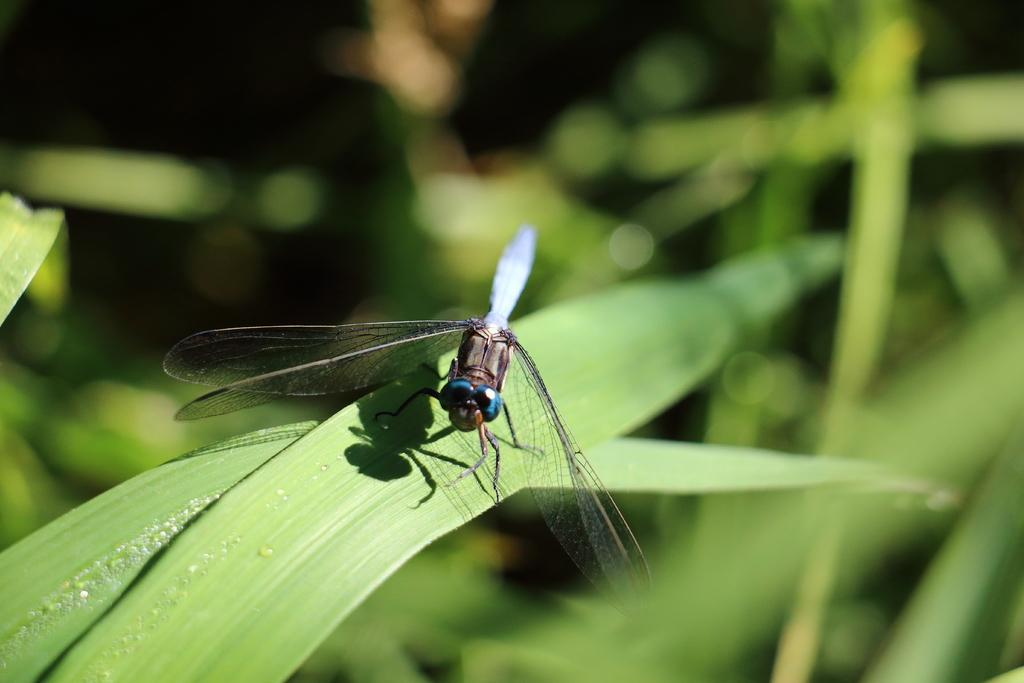What insect is present in the picture? There is a dragonfly in the picture. What are the main features of the dragonfly? The dragonfly has wings, eyes, legs, and an abdomen. What else can be seen in the picture besides the dragonfly? There are leaves in the picture. How visible are the leaves in the picture? The leaves are not clearly visible in the background. What is the name of the garden where the dragonfly was photographed? There is no information about a garden in the provided facts, and the image does not indicate the location of the dragonfly. 